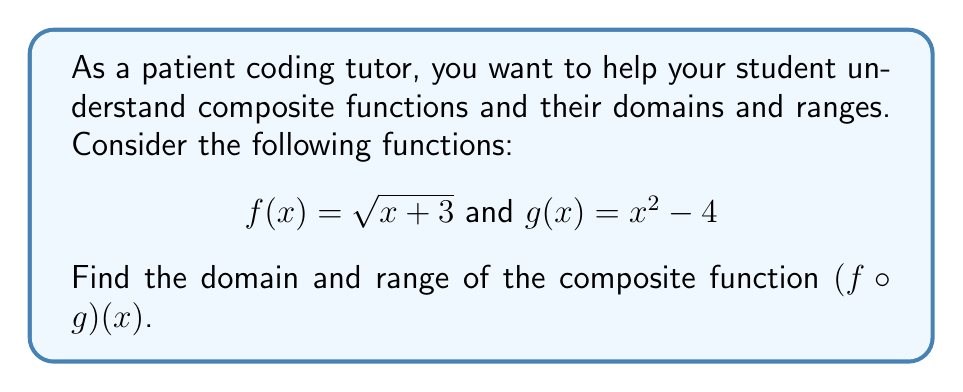Can you answer this question? Let's approach this step-by-step:

1) First, we need to find $(f \circ g)(x)$:
   $$(f \circ g)(x) = f(g(x)) = \sqrt{g(x) + 3} = \sqrt{(x^2 - 4) + 3} = \sqrt{x^2 - 1}$$

2) Now, let's consider the domain:
   - For the inner function $g(x) = x^2 - 4$, the domain is all real numbers.
   - For the outer function $f(x) = \sqrt{x + 3}$, we need $x + 3 \geq 0$, or $x \geq -3$.
   - In our composite function, we need $x^2 - 1 \geq 0$ for the square root to be defined.
   - Solving this inequality: $x^2 \geq 1$, which gives us $x \leq -1$ or $x \geq 1$.

3) For the range:
   - The expression under the square root, $x^2 - 1$, is always non-negative in the domain we found.
   - The square root function always produces non-negative results.
   - The minimum value occurs when $x^2 - 1 = 0$, i.e., when $x = \pm 1$.
   - There is no upper limit to $x^2 - 1$ as $x$ approaches infinity.

Therefore, the range is $[0, \infty)$, which means all non-negative real numbers including zero.
Answer: Domain: $(-\infty, -1] \cup [1, \infty)$
Range: $[0, \infty)$ 